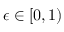<formula> <loc_0><loc_0><loc_500><loc_500>\epsilon \in [ 0 , 1 )</formula> 